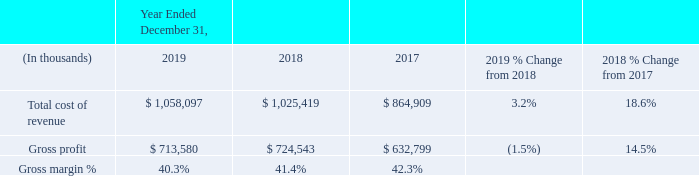Gross Profit
Year Ended December 31, 2019 Compared with the Year Ended December 31, 2018
Gross profit and margin decreased during the year ended December 31, 2019 compared to prior year primarily due to an increase in hosting migration costs, higher amortization of software development, recognition of previously deferred costs and the sale of OneContent business on April 2, 2018, which carried a higher gross margin compared with our other businesses. These were partially offset with an increase in organic sales for Veradigm and our acute solutions in 2019.
Year Ended December 31, 2018 Compared with the Year Ended December 31, 2017
Gross profit increased during the year ended December 31, 2018 compared with the year ended December 31, 2017 primarily due to acquisitions. From a revenue mix perspective, gross profit associated with our recurring revenue streams, which include the delivery of recurring subscription-based software sales, support and maintenance, and recurring client services improved as we continued to expand our customer base for these services, particularly those related to outsourcing and revenue cycle management. Gross profit associated with our non-recurring software delivery, support and maintenance revenue stream decreased primarily due to fewer perpetual software license sales of our acute and population health management solutions. Gross profit associated with our non-recurring client services revenue stream, which includes non-recurring project-based client services, decreased primarily driven by higher internal personnel costs, including those related to incremental resources from recent acquisitions. Gross margin decreased primarily due to lower sales of higher margin perpetual software licenses and higher amortization of software development and acquisition-related assets driven by additional amortization expense associated with intangible assets acquired as part of recent acquisitions.
What caused the decrease in Gross profit and margin in 2019? Primarily due to an increase in hosting migration costs, higher amortization of software development, recognition of previously deferred costs and the sale of onecontent business on april 2, 2018, which carried a higher gross margin compared with our other businesses. What was the total cost of revenue in 2019?
Answer scale should be: thousand. $ 1,058,097. What was the gross profit margin in 2019? 40.3%. What is the change in the Total cost of revenue from 2018 to 2019?
Answer scale should be: thousand. 1,058,097 - 1,025,419 
Answer: 32678. What is the average gross profit between 2017-2019?
Answer scale should be: thousand. (713,580 + 724,543 + 632,799) / 3
Answer: 690307.33. What is the change in the gross margin % from 2018 to 2019?
Answer scale should be: percent. 40.3% - 41.4%
Answer: -1.1. 